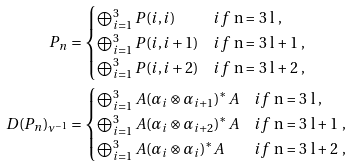<formula> <loc_0><loc_0><loc_500><loc_500>{ } P _ { n } & = \begin{cases} \bigoplus _ { i = 1 } ^ { 3 } P ( i , i ) & i f $ n = 3 l $ , \\ \bigoplus _ { i = 1 } ^ { 3 } P ( i , i + 1 ) & i f $ n = 3 l + 1 $ , \\ \bigoplus _ { i = 1 } ^ { 3 } P ( i , i + 2 ) & i f $ n = 3 l + 2 $ , \\ \end{cases} \\ D ( P _ { n } ) _ { \nu ^ { - 1 } } & = \begin{cases} \bigoplus _ { i = 1 } ^ { 3 } A ( \alpha _ { i } \otimes \alpha _ { i + 1 } ) ^ { * } A & i f $ n = 3 l $ , \\ \bigoplus _ { i = 1 } ^ { 3 } A ( \alpha _ { i } \otimes \alpha _ { i + 2 } ) ^ { * } A & i f $ n = 3 l + 1 $ , \\ \bigoplus _ { i = 1 } ^ { 3 } A ( \alpha _ { i } \otimes \alpha _ { i } ) ^ { * } A & i f $ n = 3 l + 2 $ , \\ \end{cases}</formula> 